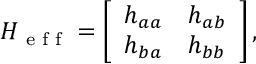<formula> <loc_0><loc_0><loc_500><loc_500>H _ { e f f } = \left [ \begin{array} { l l } { h _ { a a } } & { h _ { a b } } \\ { h _ { b a } } & { h _ { b b } } \end{array} \right ] ,</formula> 